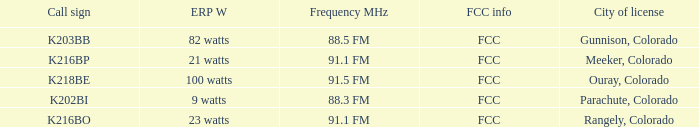Which ERP W has a Frequency MHz of 88.5 FM? 82 watts. 